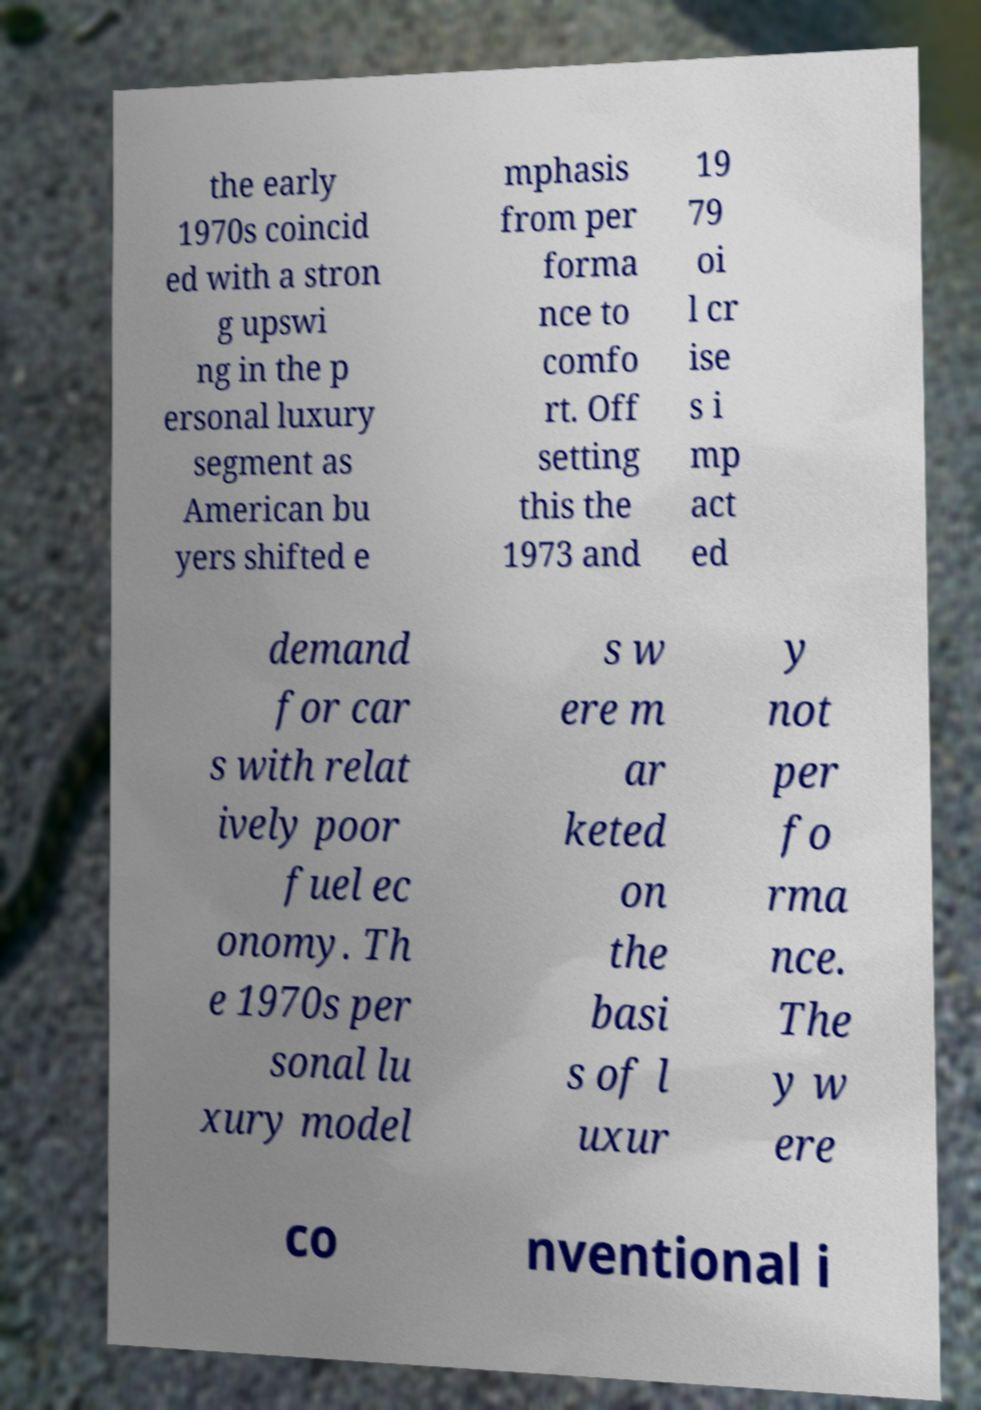I need the written content from this picture converted into text. Can you do that? the early 1970s coincid ed with a stron g upswi ng in the p ersonal luxury segment as American bu yers shifted e mphasis from per forma nce to comfo rt. Off setting this the 1973 and 19 79 oi l cr ise s i mp act ed demand for car s with relat ively poor fuel ec onomy. Th e 1970s per sonal lu xury model s w ere m ar keted on the basi s of l uxur y not per fo rma nce. The y w ere co nventional i 